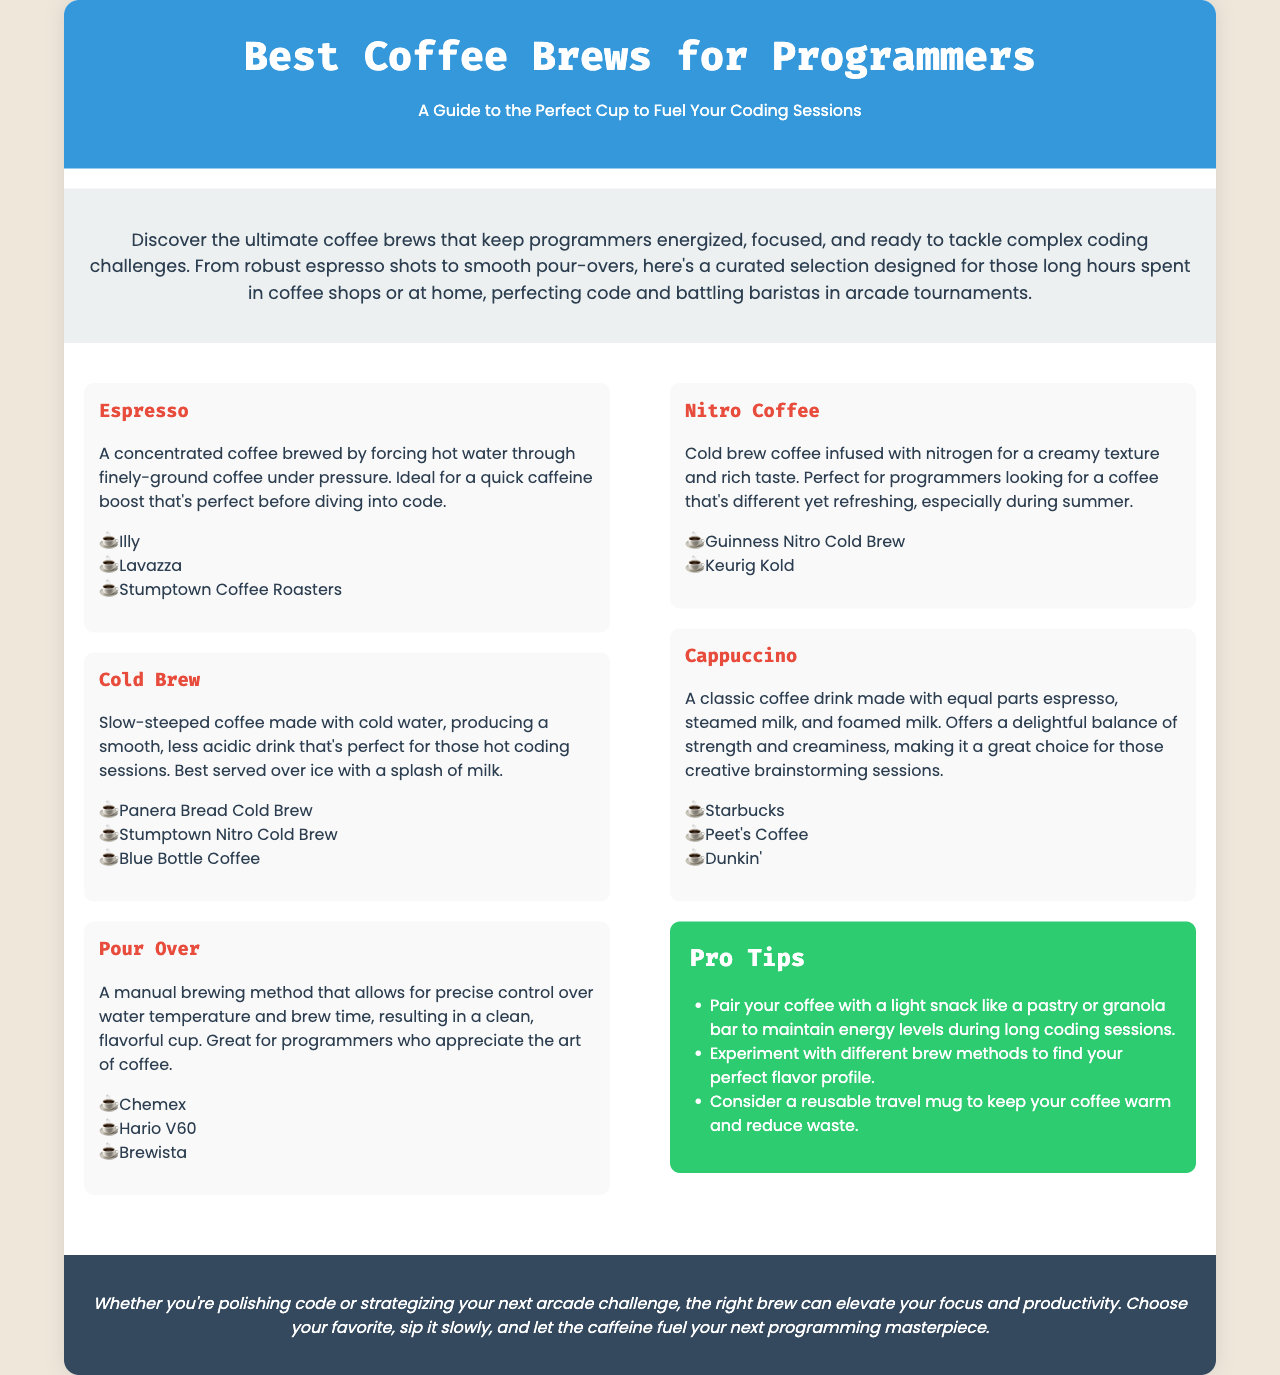What is the title of the brochure? The title of the brochure is prominently displayed at the top of the document, which is "Best Coffee Brews for Programmers".
Answer: Best Coffee Brews for Programmers What type of coffee is made by forcing hot water through finely-ground coffee? The document describes Espresso as a concentrated coffee brewed using this method.
Answer: Espresso Which coffee brew method allows for precise control over water temperature and brew time? The document mentions that Pour Over is the manual brewing method that allows for this control.
Answer: Pour Over What are the pro tips related to coffee mentioned in the brochure? The tips are contained in a dedicated section of the brochure, suggesting strategies to enhance coffee enjoyment during coding sessions.
Answer: Pair with a snack, experiment with methods, consider a travel mug Which coffee type is described as cold brew coffee infused with nitrogen? Nitro Coffee is specifically mentioned as the coffee type that is infused with nitrogen for a creamy texture.
Answer: Nitro Coffee How many coffee brews are listed in the brochure? The document contains a section on various coffee brews, listing several types including Espresso, Cold Brew, Pour Over, Nitro Coffee, and Cappuccino.
Answer: Five What color is the background of the conclusion section? The conclusion section's background color is specified and described as dark in the document.
Answer: Dark color What is recommended to maintain energy levels during long coding sessions? The brochure suggests pairing coffee with a light snack, which can help sustain energy during extended periods of coding.
Answer: Light snack 